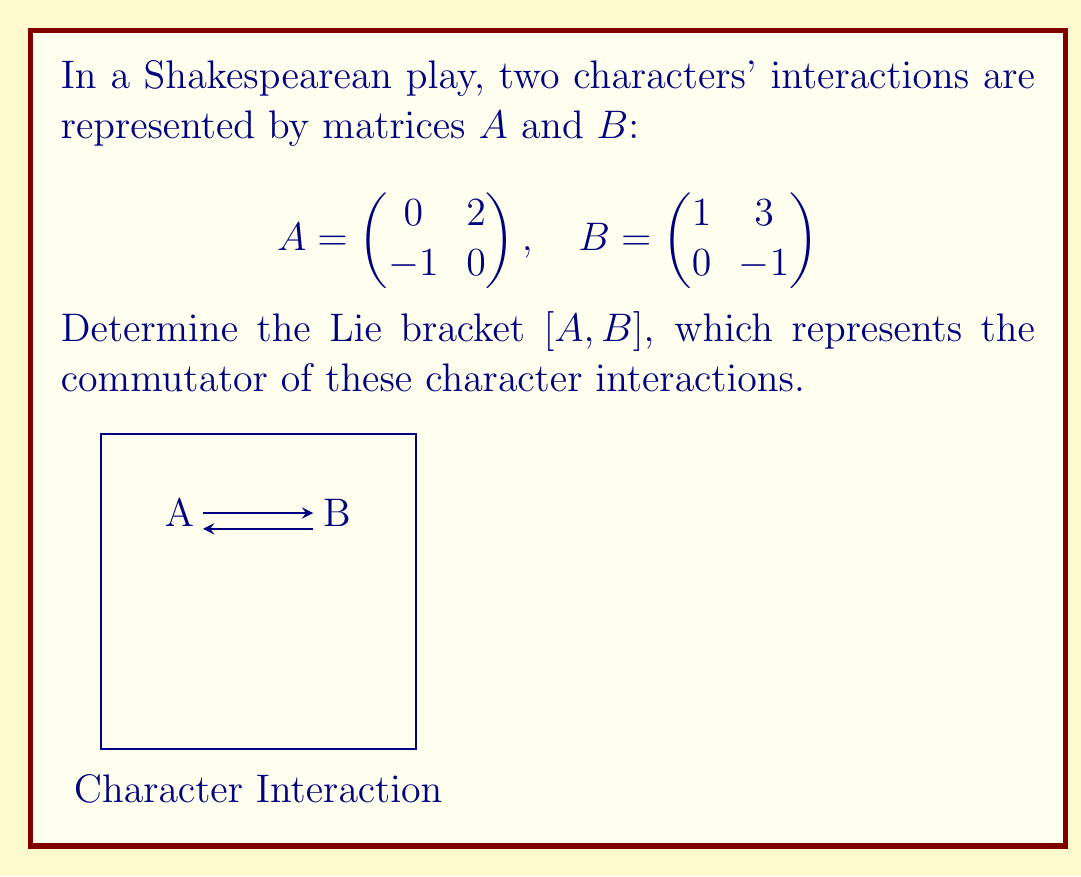Can you solve this math problem? To calculate the Lie bracket $[A,B]$, we use the formula:

$[A,B] = AB - BA$

1) First, calculate $AB$:
   $$AB = \begin{pmatrix} 0 & 2 \\ -1 & 0 \end{pmatrix} \begin{pmatrix} 1 & 3 \\ 0 & -1 \end{pmatrix} = \begin{pmatrix} 0 & -2 \\ -1 & -3 \end{pmatrix}$$

2) Next, calculate $BA$:
   $$BA = \begin{pmatrix} 1 & 3 \\ 0 & -1 \end{pmatrix} \begin{pmatrix} 0 & 2 \\ -1 & 0 \end{pmatrix} = \begin{pmatrix} -3 & 2 \\ 1 & 0 \end{pmatrix}$$

3) Now, subtract $BA$ from $AB$:
   $$[A,B] = AB - BA = \begin{pmatrix} 0 & -2 \\ -1 & -3 \end{pmatrix} - \begin{pmatrix} -3 & 2 \\ 1 & 0 \end{pmatrix} = \begin{pmatrix} 3 & -4 \\ -2 & -3 \end{pmatrix}$$

This result represents the commutator of the character interactions in the play.
Answer: $[A,B] = \begin{pmatrix} 3 & -4 \\ -2 & -3 \end{pmatrix}$ 